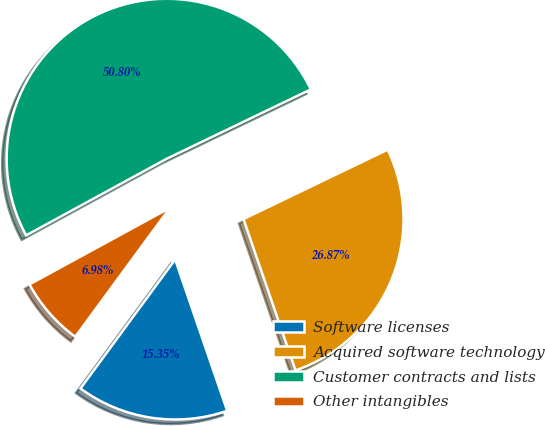Convert chart. <chart><loc_0><loc_0><loc_500><loc_500><pie_chart><fcel>Software licenses<fcel>Acquired software technology<fcel>Customer contracts and lists<fcel>Other intangibles<nl><fcel>15.35%<fcel>26.87%<fcel>50.8%<fcel>6.98%<nl></chart> 